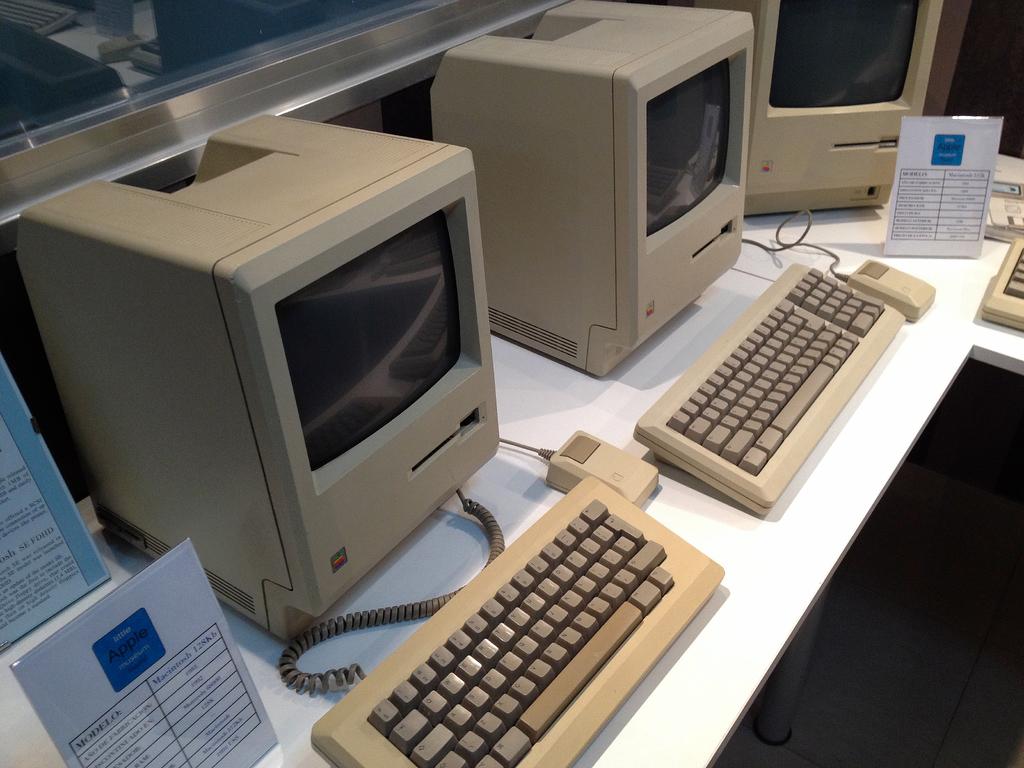How many kb does the macintosh have?
Keep it short and to the point. 128. What company made the computer?
Your answer should be compact. Apple. 